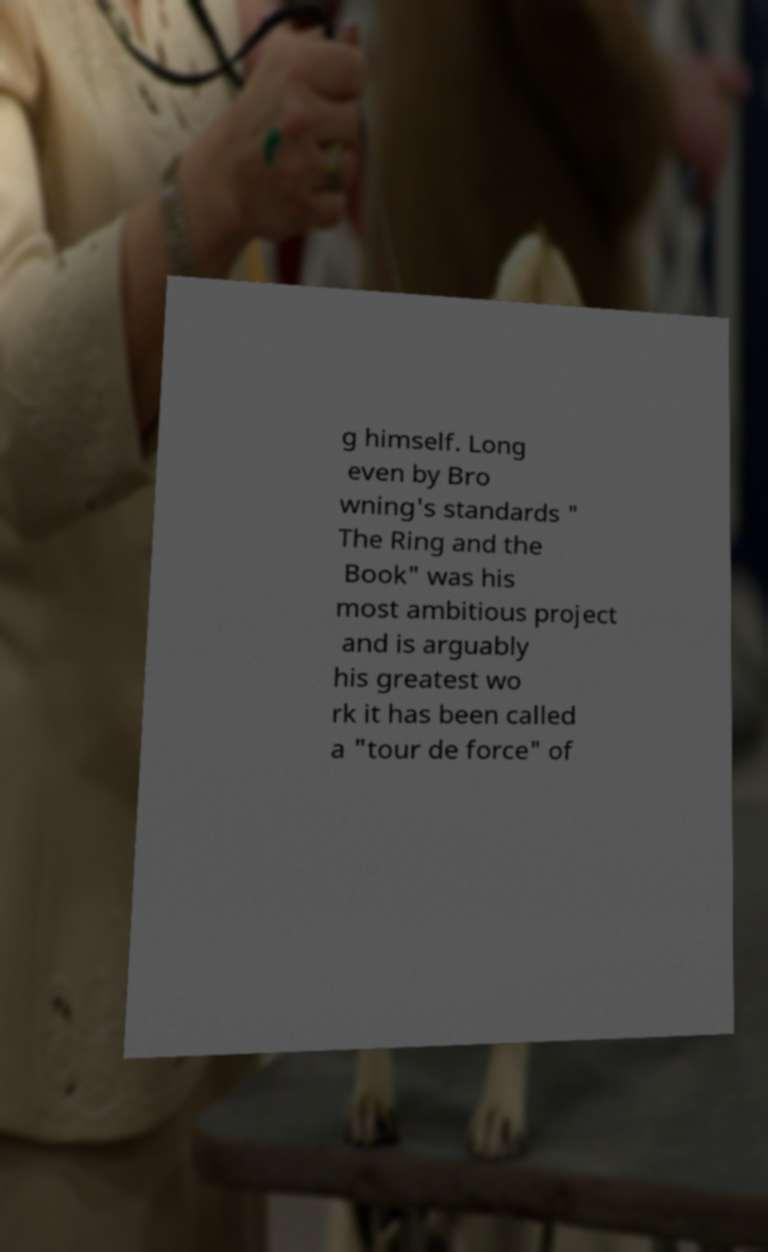For documentation purposes, I need the text within this image transcribed. Could you provide that? g himself. Long even by Bro wning's standards " The Ring and the Book" was his most ambitious project and is arguably his greatest wo rk it has been called a "tour de force" of 